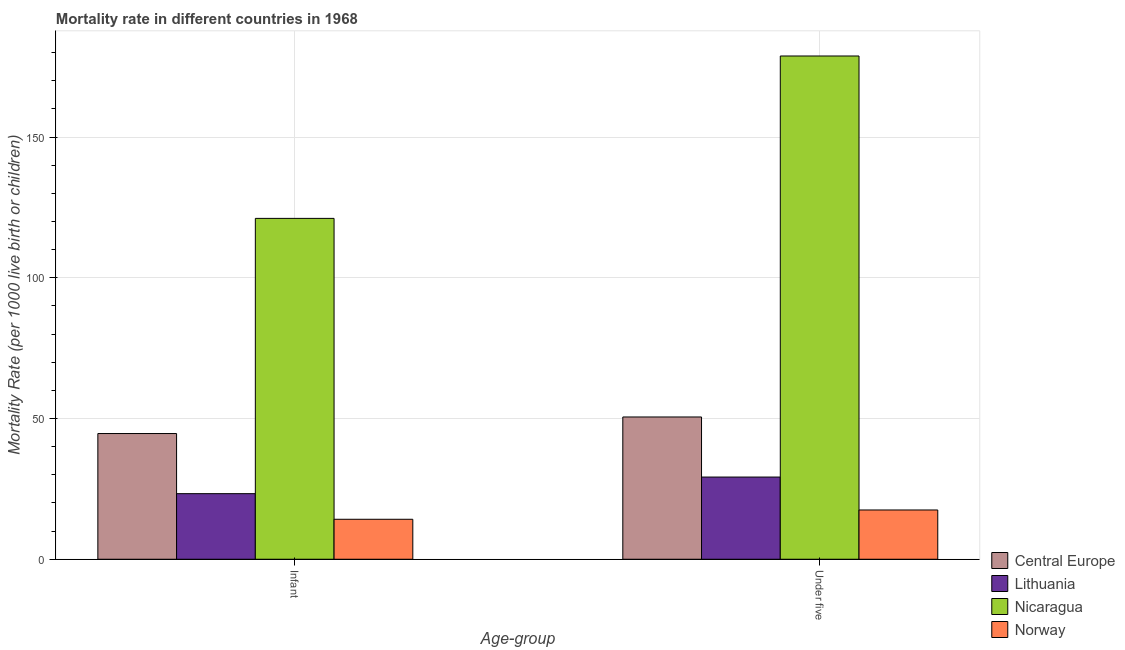How many groups of bars are there?
Your response must be concise. 2. Are the number of bars per tick equal to the number of legend labels?
Ensure brevity in your answer.  Yes. Are the number of bars on each tick of the X-axis equal?
Provide a succinct answer. Yes. What is the label of the 2nd group of bars from the left?
Your answer should be very brief. Under five. What is the under-5 mortality rate in Central Europe?
Offer a terse response. 50.55. Across all countries, what is the maximum infant mortality rate?
Give a very brief answer. 121.1. In which country was the infant mortality rate maximum?
Your answer should be very brief. Nicaragua. In which country was the under-5 mortality rate minimum?
Your answer should be compact. Norway. What is the total under-5 mortality rate in the graph?
Your response must be concise. 276.05. What is the difference between the under-5 mortality rate in Nicaragua and that in Norway?
Provide a succinct answer. 161.3. What is the difference between the under-5 mortality rate in Nicaragua and the infant mortality rate in Central Europe?
Provide a succinct answer. 134.14. What is the average under-5 mortality rate per country?
Ensure brevity in your answer.  69.01. What is the difference between the under-5 mortality rate and infant mortality rate in Norway?
Make the answer very short. 3.3. What is the ratio of the under-5 mortality rate in Lithuania to that in Nicaragua?
Provide a succinct answer. 0.16. Is the under-5 mortality rate in Lithuania less than that in Nicaragua?
Give a very brief answer. Yes. What does the 3rd bar from the left in Infant represents?
Keep it short and to the point. Nicaragua. What does the 3rd bar from the right in Under five represents?
Keep it short and to the point. Lithuania. How many bars are there?
Provide a succinct answer. 8. Are all the bars in the graph horizontal?
Keep it short and to the point. No. How many countries are there in the graph?
Ensure brevity in your answer.  4. Are the values on the major ticks of Y-axis written in scientific E-notation?
Your answer should be very brief. No. Does the graph contain grids?
Make the answer very short. Yes. How are the legend labels stacked?
Your answer should be compact. Vertical. What is the title of the graph?
Provide a succinct answer. Mortality rate in different countries in 1968. What is the label or title of the X-axis?
Give a very brief answer. Age-group. What is the label or title of the Y-axis?
Keep it short and to the point. Mortality Rate (per 1000 live birth or children). What is the Mortality Rate (per 1000 live birth or children) in Central Europe in Infant?
Keep it short and to the point. 44.66. What is the Mortality Rate (per 1000 live birth or children) in Lithuania in Infant?
Your answer should be compact. 23.3. What is the Mortality Rate (per 1000 live birth or children) of Nicaragua in Infant?
Your response must be concise. 121.1. What is the Mortality Rate (per 1000 live birth or children) of Norway in Infant?
Your answer should be compact. 14.2. What is the Mortality Rate (per 1000 live birth or children) in Central Europe in Under five?
Your response must be concise. 50.55. What is the Mortality Rate (per 1000 live birth or children) in Lithuania in Under five?
Provide a short and direct response. 29.2. What is the Mortality Rate (per 1000 live birth or children) of Nicaragua in Under five?
Your answer should be very brief. 178.8. Across all Age-group, what is the maximum Mortality Rate (per 1000 live birth or children) of Central Europe?
Give a very brief answer. 50.55. Across all Age-group, what is the maximum Mortality Rate (per 1000 live birth or children) in Lithuania?
Offer a terse response. 29.2. Across all Age-group, what is the maximum Mortality Rate (per 1000 live birth or children) of Nicaragua?
Keep it short and to the point. 178.8. Across all Age-group, what is the minimum Mortality Rate (per 1000 live birth or children) in Central Europe?
Your answer should be compact. 44.66. Across all Age-group, what is the minimum Mortality Rate (per 1000 live birth or children) of Lithuania?
Your response must be concise. 23.3. Across all Age-group, what is the minimum Mortality Rate (per 1000 live birth or children) in Nicaragua?
Offer a terse response. 121.1. What is the total Mortality Rate (per 1000 live birth or children) of Central Europe in the graph?
Ensure brevity in your answer.  95.2. What is the total Mortality Rate (per 1000 live birth or children) in Lithuania in the graph?
Provide a short and direct response. 52.5. What is the total Mortality Rate (per 1000 live birth or children) of Nicaragua in the graph?
Ensure brevity in your answer.  299.9. What is the total Mortality Rate (per 1000 live birth or children) of Norway in the graph?
Offer a terse response. 31.7. What is the difference between the Mortality Rate (per 1000 live birth or children) of Central Europe in Infant and that in Under five?
Provide a succinct answer. -5.89. What is the difference between the Mortality Rate (per 1000 live birth or children) in Lithuania in Infant and that in Under five?
Make the answer very short. -5.9. What is the difference between the Mortality Rate (per 1000 live birth or children) of Nicaragua in Infant and that in Under five?
Provide a succinct answer. -57.7. What is the difference between the Mortality Rate (per 1000 live birth or children) of Central Europe in Infant and the Mortality Rate (per 1000 live birth or children) of Lithuania in Under five?
Your response must be concise. 15.46. What is the difference between the Mortality Rate (per 1000 live birth or children) in Central Europe in Infant and the Mortality Rate (per 1000 live birth or children) in Nicaragua in Under five?
Keep it short and to the point. -134.14. What is the difference between the Mortality Rate (per 1000 live birth or children) of Central Europe in Infant and the Mortality Rate (per 1000 live birth or children) of Norway in Under five?
Your answer should be compact. 27.16. What is the difference between the Mortality Rate (per 1000 live birth or children) of Lithuania in Infant and the Mortality Rate (per 1000 live birth or children) of Nicaragua in Under five?
Your response must be concise. -155.5. What is the difference between the Mortality Rate (per 1000 live birth or children) in Lithuania in Infant and the Mortality Rate (per 1000 live birth or children) in Norway in Under five?
Make the answer very short. 5.8. What is the difference between the Mortality Rate (per 1000 live birth or children) of Nicaragua in Infant and the Mortality Rate (per 1000 live birth or children) of Norway in Under five?
Provide a short and direct response. 103.6. What is the average Mortality Rate (per 1000 live birth or children) in Central Europe per Age-group?
Ensure brevity in your answer.  47.6. What is the average Mortality Rate (per 1000 live birth or children) of Lithuania per Age-group?
Your response must be concise. 26.25. What is the average Mortality Rate (per 1000 live birth or children) in Nicaragua per Age-group?
Offer a terse response. 149.95. What is the average Mortality Rate (per 1000 live birth or children) in Norway per Age-group?
Make the answer very short. 15.85. What is the difference between the Mortality Rate (per 1000 live birth or children) in Central Europe and Mortality Rate (per 1000 live birth or children) in Lithuania in Infant?
Your answer should be compact. 21.36. What is the difference between the Mortality Rate (per 1000 live birth or children) of Central Europe and Mortality Rate (per 1000 live birth or children) of Nicaragua in Infant?
Provide a succinct answer. -76.44. What is the difference between the Mortality Rate (per 1000 live birth or children) of Central Europe and Mortality Rate (per 1000 live birth or children) of Norway in Infant?
Your answer should be compact. 30.46. What is the difference between the Mortality Rate (per 1000 live birth or children) in Lithuania and Mortality Rate (per 1000 live birth or children) in Nicaragua in Infant?
Provide a short and direct response. -97.8. What is the difference between the Mortality Rate (per 1000 live birth or children) of Lithuania and Mortality Rate (per 1000 live birth or children) of Norway in Infant?
Your answer should be compact. 9.1. What is the difference between the Mortality Rate (per 1000 live birth or children) in Nicaragua and Mortality Rate (per 1000 live birth or children) in Norway in Infant?
Your response must be concise. 106.9. What is the difference between the Mortality Rate (per 1000 live birth or children) of Central Europe and Mortality Rate (per 1000 live birth or children) of Lithuania in Under five?
Give a very brief answer. 21.35. What is the difference between the Mortality Rate (per 1000 live birth or children) of Central Europe and Mortality Rate (per 1000 live birth or children) of Nicaragua in Under five?
Offer a terse response. -128.25. What is the difference between the Mortality Rate (per 1000 live birth or children) in Central Europe and Mortality Rate (per 1000 live birth or children) in Norway in Under five?
Your answer should be compact. 33.05. What is the difference between the Mortality Rate (per 1000 live birth or children) in Lithuania and Mortality Rate (per 1000 live birth or children) in Nicaragua in Under five?
Provide a succinct answer. -149.6. What is the difference between the Mortality Rate (per 1000 live birth or children) in Lithuania and Mortality Rate (per 1000 live birth or children) in Norway in Under five?
Give a very brief answer. 11.7. What is the difference between the Mortality Rate (per 1000 live birth or children) in Nicaragua and Mortality Rate (per 1000 live birth or children) in Norway in Under five?
Your response must be concise. 161.3. What is the ratio of the Mortality Rate (per 1000 live birth or children) of Central Europe in Infant to that in Under five?
Ensure brevity in your answer.  0.88. What is the ratio of the Mortality Rate (per 1000 live birth or children) in Lithuania in Infant to that in Under five?
Your response must be concise. 0.8. What is the ratio of the Mortality Rate (per 1000 live birth or children) in Nicaragua in Infant to that in Under five?
Offer a very short reply. 0.68. What is the ratio of the Mortality Rate (per 1000 live birth or children) in Norway in Infant to that in Under five?
Ensure brevity in your answer.  0.81. What is the difference between the highest and the second highest Mortality Rate (per 1000 live birth or children) of Central Europe?
Ensure brevity in your answer.  5.89. What is the difference between the highest and the second highest Mortality Rate (per 1000 live birth or children) of Lithuania?
Provide a short and direct response. 5.9. What is the difference between the highest and the second highest Mortality Rate (per 1000 live birth or children) in Nicaragua?
Make the answer very short. 57.7. What is the difference between the highest and the second highest Mortality Rate (per 1000 live birth or children) of Norway?
Give a very brief answer. 3.3. What is the difference between the highest and the lowest Mortality Rate (per 1000 live birth or children) of Central Europe?
Ensure brevity in your answer.  5.89. What is the difference between the highest and the lowest Mortality Rate (per 1000 live birth or children) of Lithuania?
Provide a short and direct response. 5.9. What is the difference between the highest and the lowest Mortality Rate (per 1000 live birth or children) of Nicaragua?
Your answer should be very brief. 57.7. What is the difference between the highest and the lowest Mortality Rate (per 1000 live birth or children) in Norway?
Make the answer very short. 3.3. 